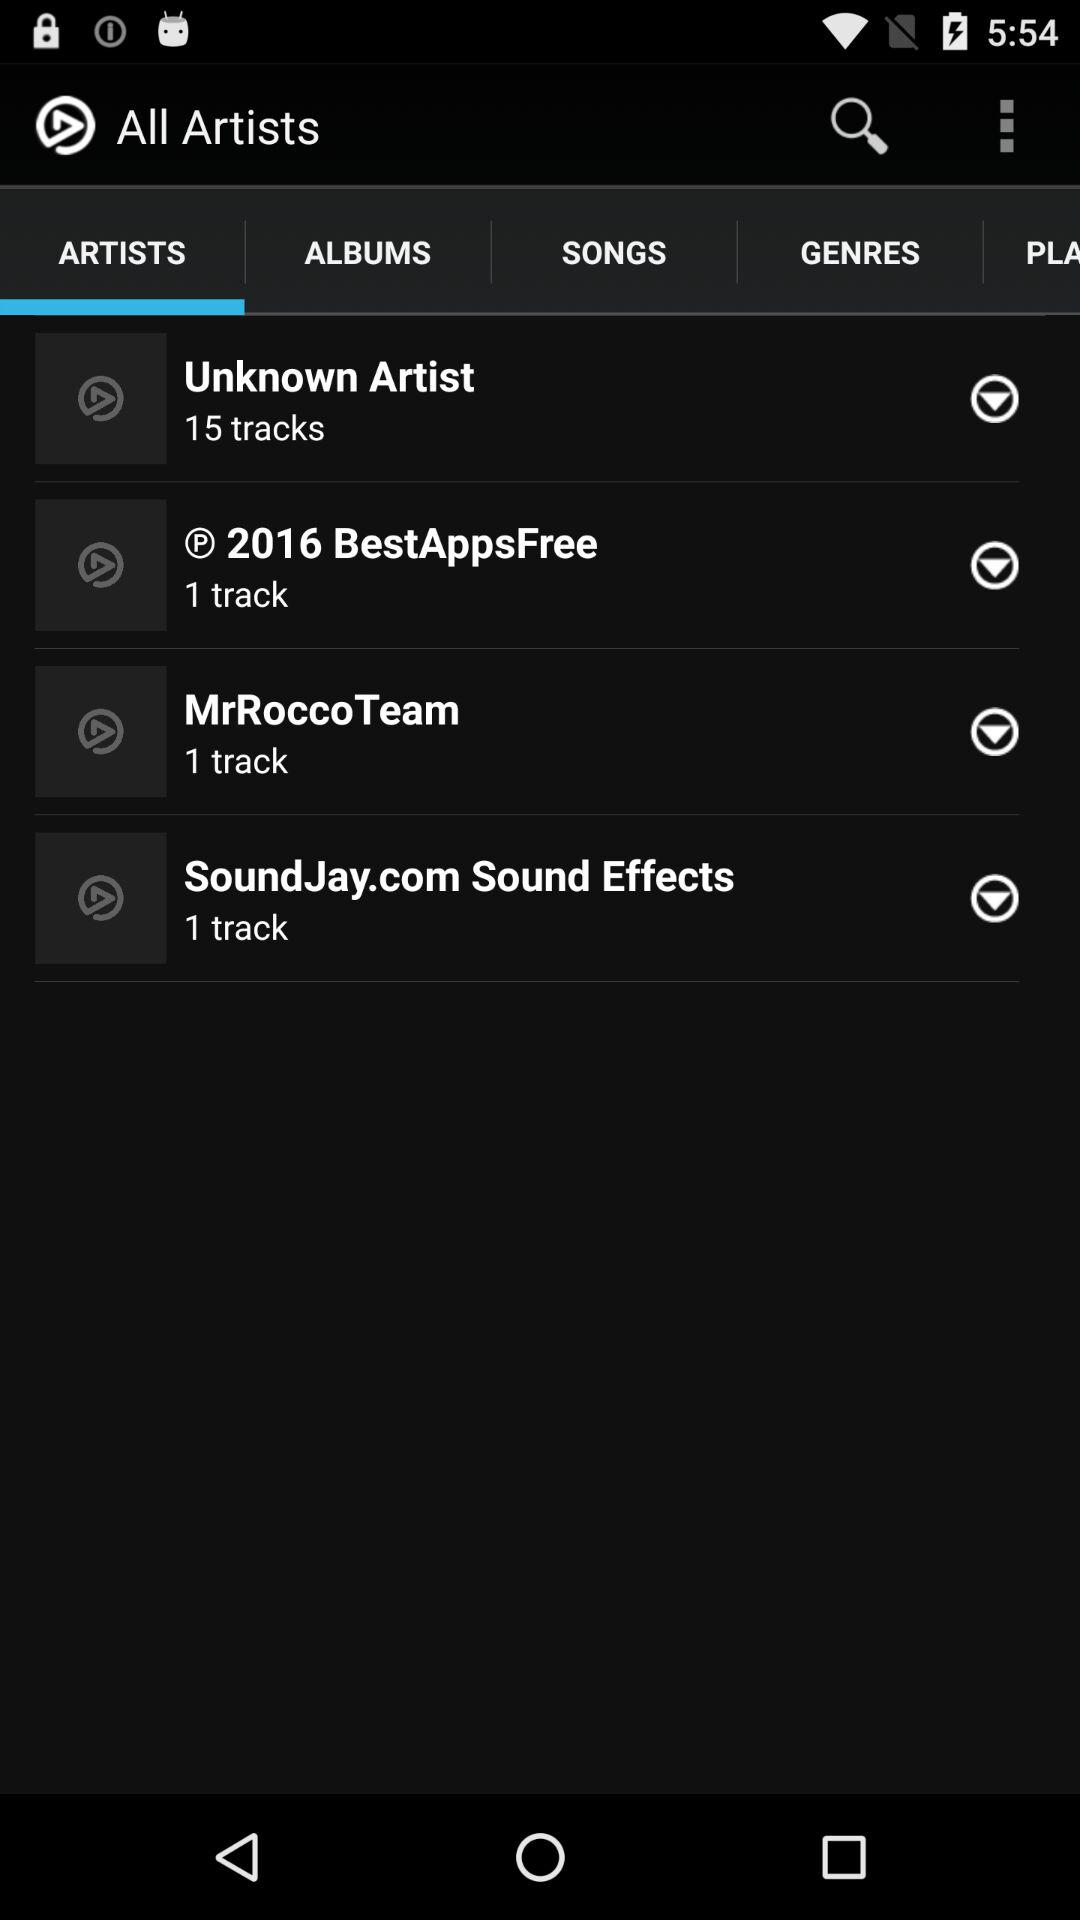How many more tracks are there by Unknown Artist than by R 2016 BestAppsFree?
Answer the question using a single word or phrase. 14 